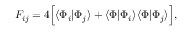Convert formula to latex. <formula><loc_0><loc_0><loc_500><loc_500>F _ { i j } = 4 \left [ \langle \Phi _ { i } | \Phi _ { j } \rangle + \langle \Phi | \Phi _ { i } \rangle \langle \Phi | \Phi _ { j } \rangle \right ] ,</formula> 